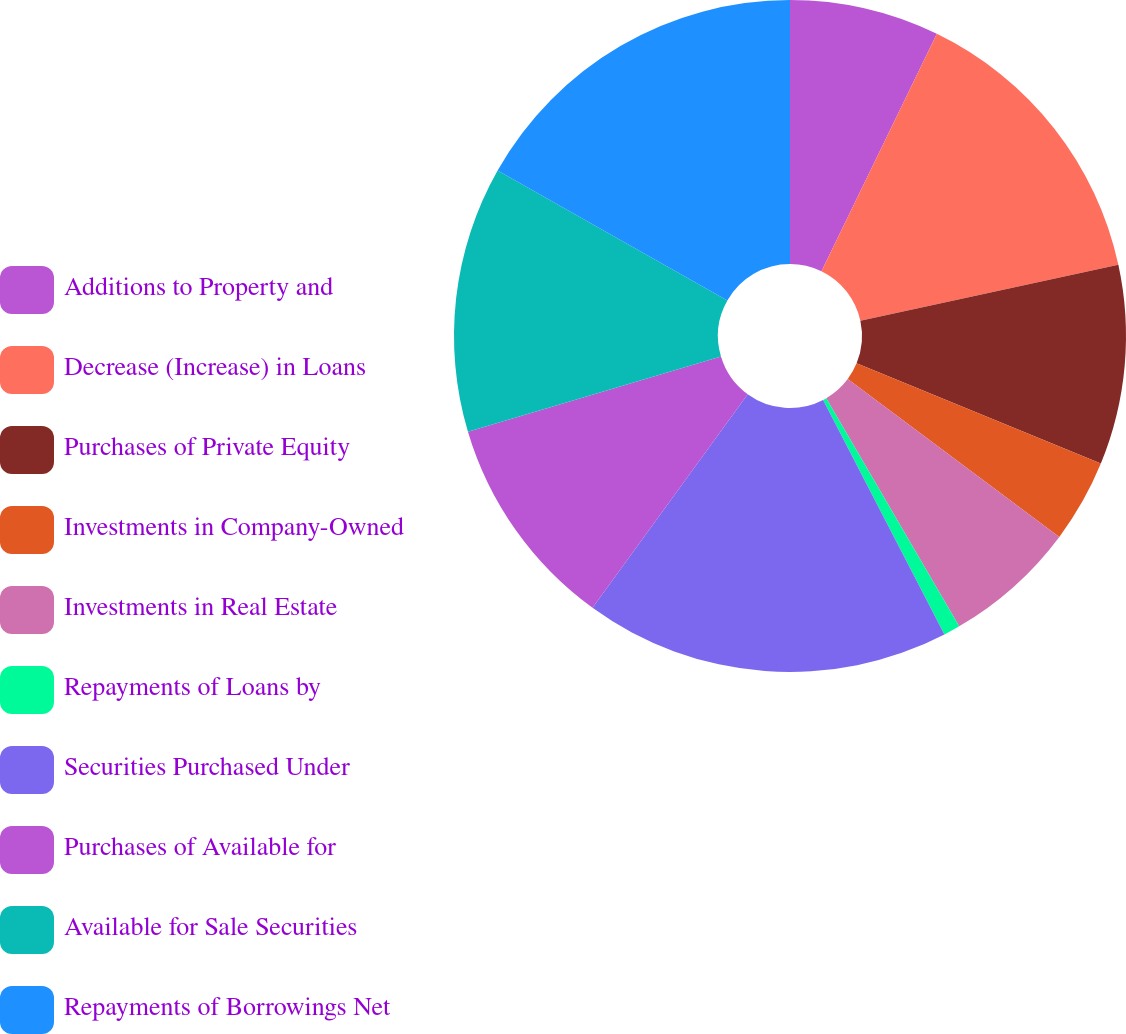<chart> <loc_0><loc_0><loc_500><loc_500><pie_chart><fcel>Additions to Property and<fcel>Decrease (Increase) in Loans<fcel>Purchases of Private Equity<fcel>Investments in Company-Owned<fcel>Investments in Real Estate<fcel>Repayments of Loans by<fcel>Securities Purchased Under<fcel>Purchases of Available for<fcel>Available for Sale Securities<fcel>Repayments of Borrowings Net<nl><fcel>7.2%<fcel>14.4%<fcel>9.6%<fcel>4.0%<fcel>6.4%<fcel>0.8%<fcel>17.6%<fcel>10.4%<fcel>12.8%<fcel>16.8%<nl></chart> 